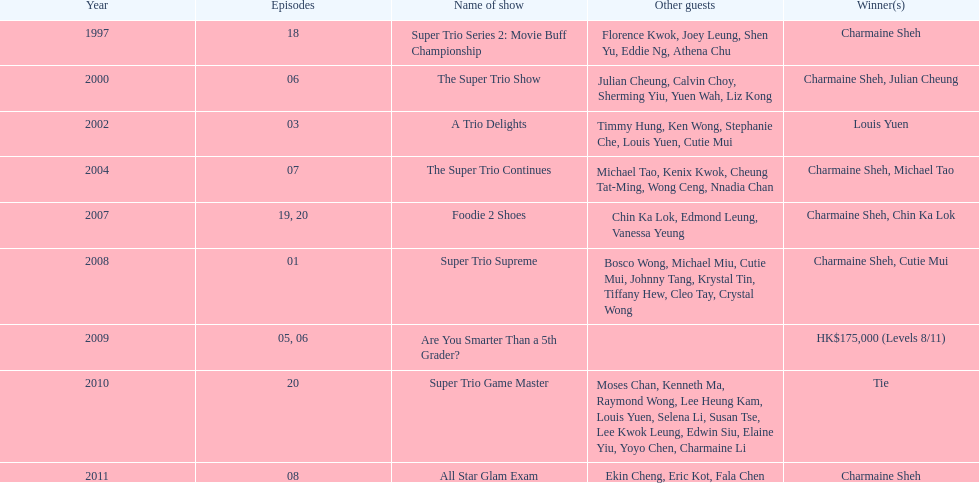How long has it been since chermaine sheh first appeared on a variety show? 17 years. 